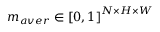<formula> <loc_0><loc_0><loc_500><loc_500>m _ { a v e r } \in \left [ 0 , 1 \right ] ^ { N \times H \times W }</formula> 